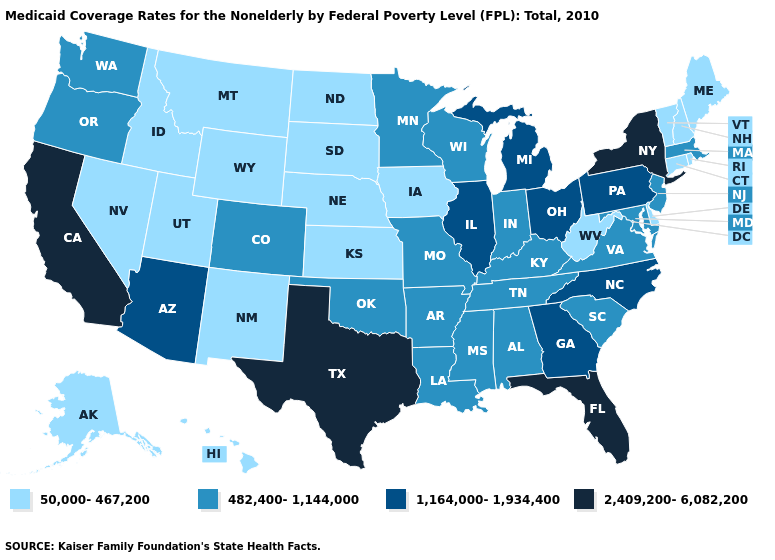Among the states that border California , does Oregon have the lowest value?
Quick response, please. No. Does Hawaii have the lowest value in the USA?
Answer briefly. Yes. Name the states that have a value in the range 50,000-467,200?
Keep it brief. Alaska, Connecticut, Delaware, Hawaii, Idaho, Iowa, Kansas, Maine, Montana, Nebraska, Nevada, New Hampshire, New Mexico, North Dakota, Rhode Island, South Dakota, Utah, Vermont, West Virginia, Wyoming. Does New Jersey have the highest value in the USA?
Concise answer only. No. Among the states that border Massachusetts , does Connecticut have the lowest value?
Give a very brief answer. Yes. Name the states that have a value in the range 1,164,000-1,934,400?
Keep it brief. Arizona, Georgia, Illinois, Michigan, North Carolina, Ohio, Pennsylvania. Does Wisconsin have the highest value in the USA?
Concise answer only. No. Name the states that have a value in the range 2,409,200-6,082,200?
Be succinct. California, Florida, New York, Texas. Does Texas have the highest value in the USA?
Write a very short answer. Yes. Among the states that border New Hampshire , does Vermont have the highest value?
Give a very brief answer. No. What is the lowest value in the Northeast?
Keep it brief. 50,000-467,200. Does Illinois have the highest value in the MidWest?
Concise answer only. Yes. Name the states that have a value in the range 1,164,000-1,934,400?
Be succinct. Arizona, Georgia, Illinois, Michigan, North Carolina, Ohio, Pennsylvania. What is the value of Nebraska?
Concise answer only. 50,000-467,200. Does Florida have the highest value in the USA?
Be succinct. Yes. 